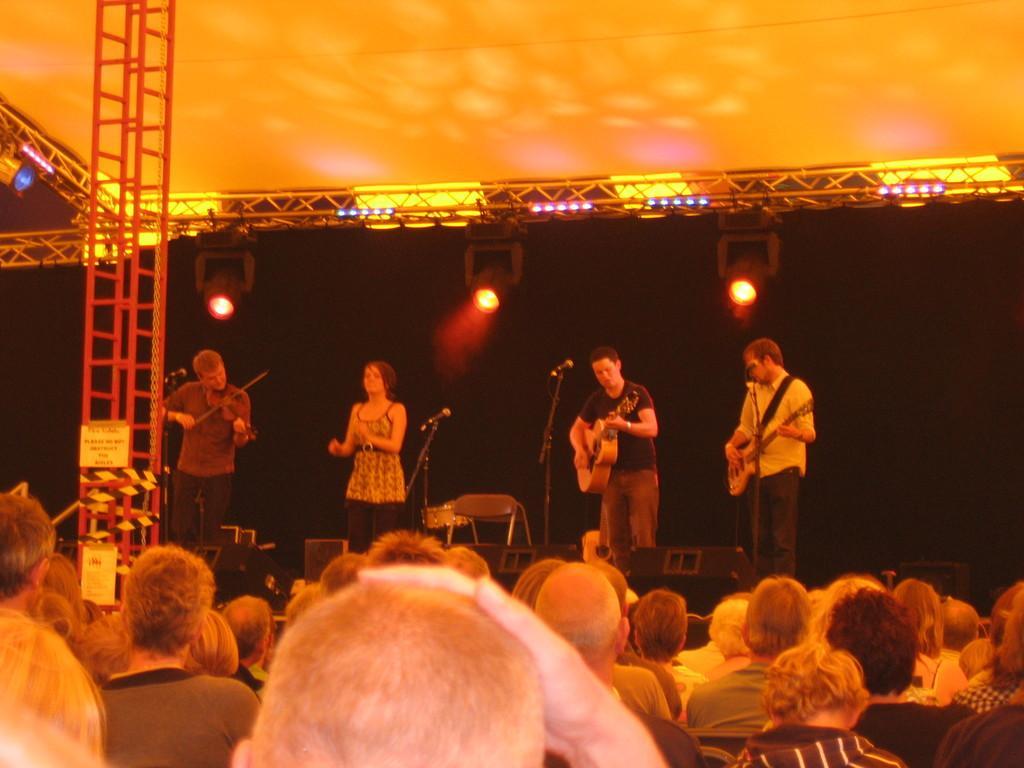In one or two sentences, can you explain what this image depicts? There are group of people standing on stage playing guitar in front of microphone and so many other people watching them. 